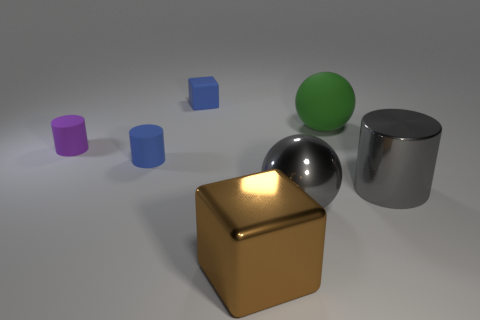Can you describe the atmosphere or mood that this image conveys? The image has a clean and simplistic aesthetic, giving off a calm and almost sterile atmosphere. The soft lighting and gentle shadows contribute to an overall tranquil and undisturbed mood, perfect for highlighting the geometry and materials of the objects. 